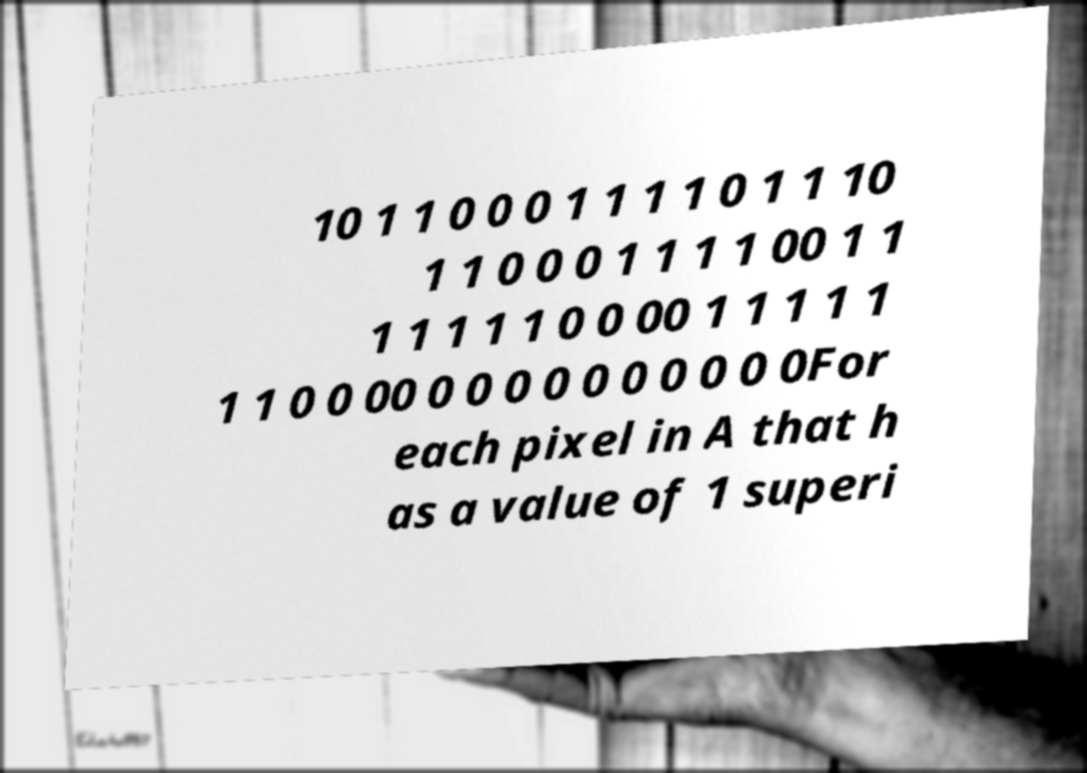I need the written content from this picture converted into text. Can you do that? 10 1 1 0 0 0 1 1 1 1 0 1 1 10 1 1 0 0 0 1 1 1 1 00 1 1 1 1 1 1 1 0 0 00 1 1 1 1 1 1 1 0 0 00 0 0 0 0 0 0 0 0 0 0For each pixel in A that h as a value of 1 superi 